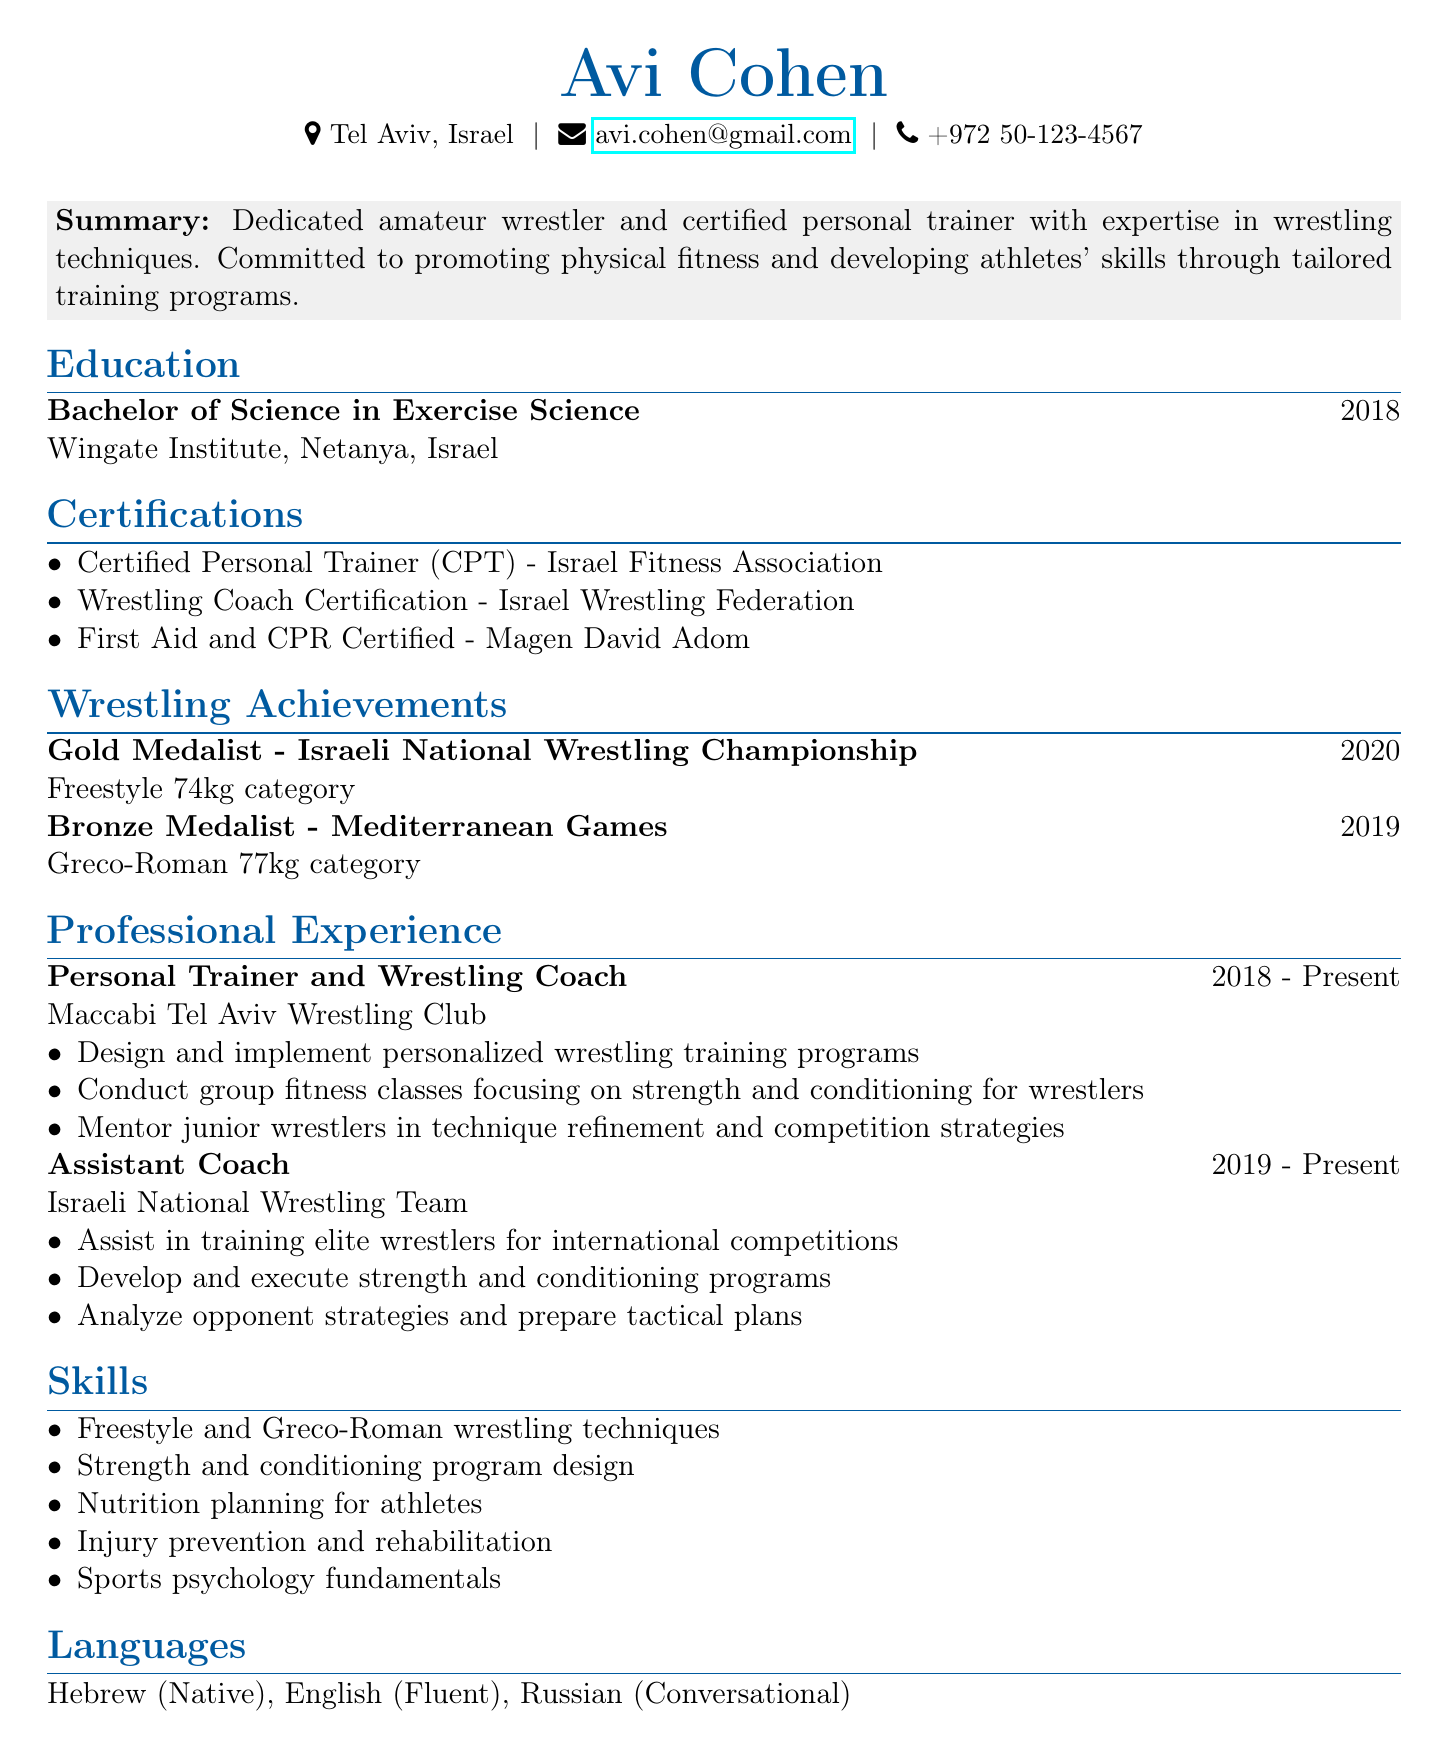What is Avi Cohen's location? The location of Avi Cohen is stated in the personal information section of the document.
Answer: Tel Aviv, Israel What certification does Avi have related to personal training? The document lists certifications, one of which is specifically for personal training.
Answer: Certified Personal Trainer (CPT) - Israel Fitness Association In which year did Avi become a gold medalist? The document specifies the year of his achievement in the wrestling championships.
Answer: 2020 What position does Avi currently hold at Maccabi Tel Aviv Wrestling Club? The title of the position is explicitly mentioned in the work experience section.
Answer: Personal Trainer and Wrestling Coach How many years has Avi been working as an assistant coach for the Israeli National Wrestling Team? This can be calculated based on the duration listed for that position in the document.
Answer: 4 years What is one of the skills listed by Avi? Skills are listed in a specific section of the document, with several examples provided.
Answer: Freestyle and Greco-Roman wrestling techniques What language does Avi speak fluently? The languages spoken are outlined in the languages section of the document.
Answer: English What medal did Avi win at the Mediterranean Games? The document details Avi's achievements in specific competitions, including the medal won.
Answer: Bronze Medalist What is the highest weight category in which Avi competed at the National Championship? This information can be found under his wrestling achievements detailing the category in which he won a medal.
Answer: Freestyle 74kg 